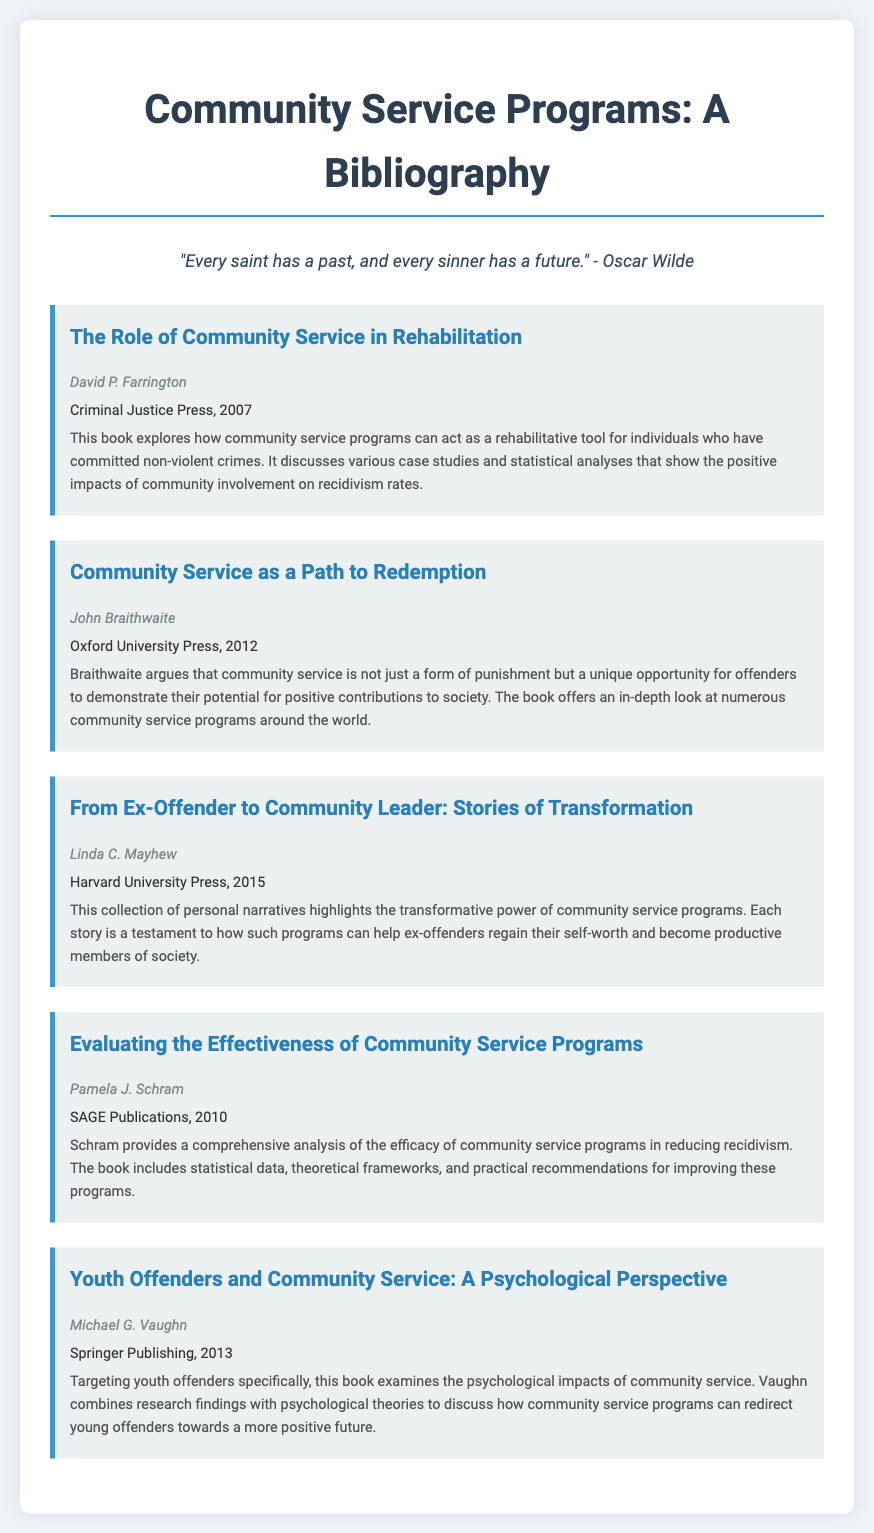What is the title of the first entry? The title of the first entry is the first line provided under the first entry in the document.
Answer: The Role of Community Service in Rehabilitation Who is the author of the book titled "Community Service as a Path to Redemption"? The author is noted directly below the title of the second entry in the document.
Answer: John Braithwaite In what year was "From Ex-Offender to Community Leader: Stories of Transformation" published? The publication year is mentioned immediately after the author's name for that entry.
Answer: 2015 What is the main focus of Michael G. Vaughn's book? The focus is detailed in the summary section of the fifth entry, indicating the psychological focus related to youth offenders.
Answer: Psychological impacts of community service How many entries feature a publication year after 2010? To find this, we count the entries where the published year is greater than 2010.
Answer: 3 What unique perspective does Pamela J. Schram discuss in her book? This information is found in the summary of her entry, as it mentions the analysis of community service programs' results.
Answer: Effectiveness of community service programs How many total entries are included in the bibliography? This is determined by counting all the distinct entries listed in the document.
Answer: 5 What does the quote at the top convey about people? The quote highlights a theme of hope and redemption, as it discusses the past and future of individuals.
Answer: Redemption 